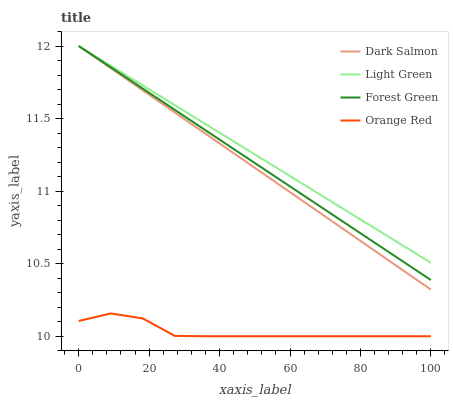Does Orange Red have the minimum area under the curve?
Answer yes or no. Yes. Does Light Green have the maximum area under the curve?
Answer yes or no. Yes. Does Dark Salmon have the minimum area under the curve?
Answer yes or no. No. Does Dark Salmon have the maximum area under the curve?
Answer yes or no. No. Is Dark Salmon the smoothest?
Answer yes or no. Yes. Is Orange Red the roughest?
Answer yes or no. Yes. Is Light Green the smoothest?
Answer yes or no. No. Is Light Green the roughest?
Answer yes or no. No. Does Orange Red have the lowest value?
Answer yes or no. Yes. Does Dark Salmon have the lowest value?
Answer yes or no. No. Does Light Green have the highest value?
Answer yes or no. Yes. Does Orange Red have the highest value?
Answer yes or no. No. Is Orange Red less than Forest Green?
Answer yes or no. Yes. Is Light Green greater than Orange Red?
Answer yes or no. Yes. Does Light Green intersect Dark Salmon?
Answer yes or no. Yes. Is Light Green less than Dark Salmon?
Answer yes or no. No. Is Light Green greater than Dark Salmon?
Answer yes or no. No. Does Orange Red intersect Forest Green?
Answer yes or no. No. 